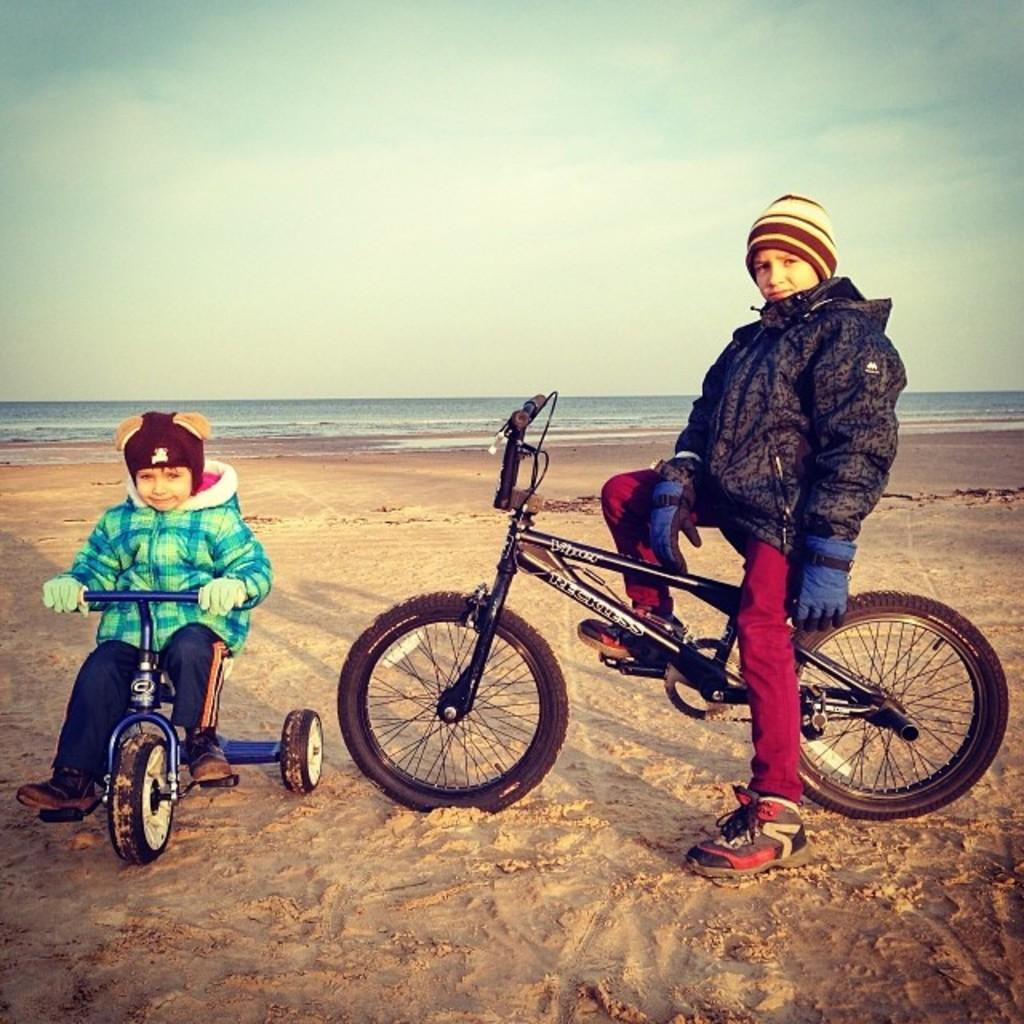How many people are in the image? There are 2 people in the image. What are the people doing in the image? The people are sitting on a bicycle. Where is the bicycle located? The bicycle is on a beach. What can be seen behind the people? There is water visible behind the people. What type of cast can be seen on the person's arm in the image? There is no cast visible on anyone's arm in the image. How much sand is present on the beach in the image? The image does not provide information about the amount of sand on the beach; it only shows that the bicycle is on a beach. 